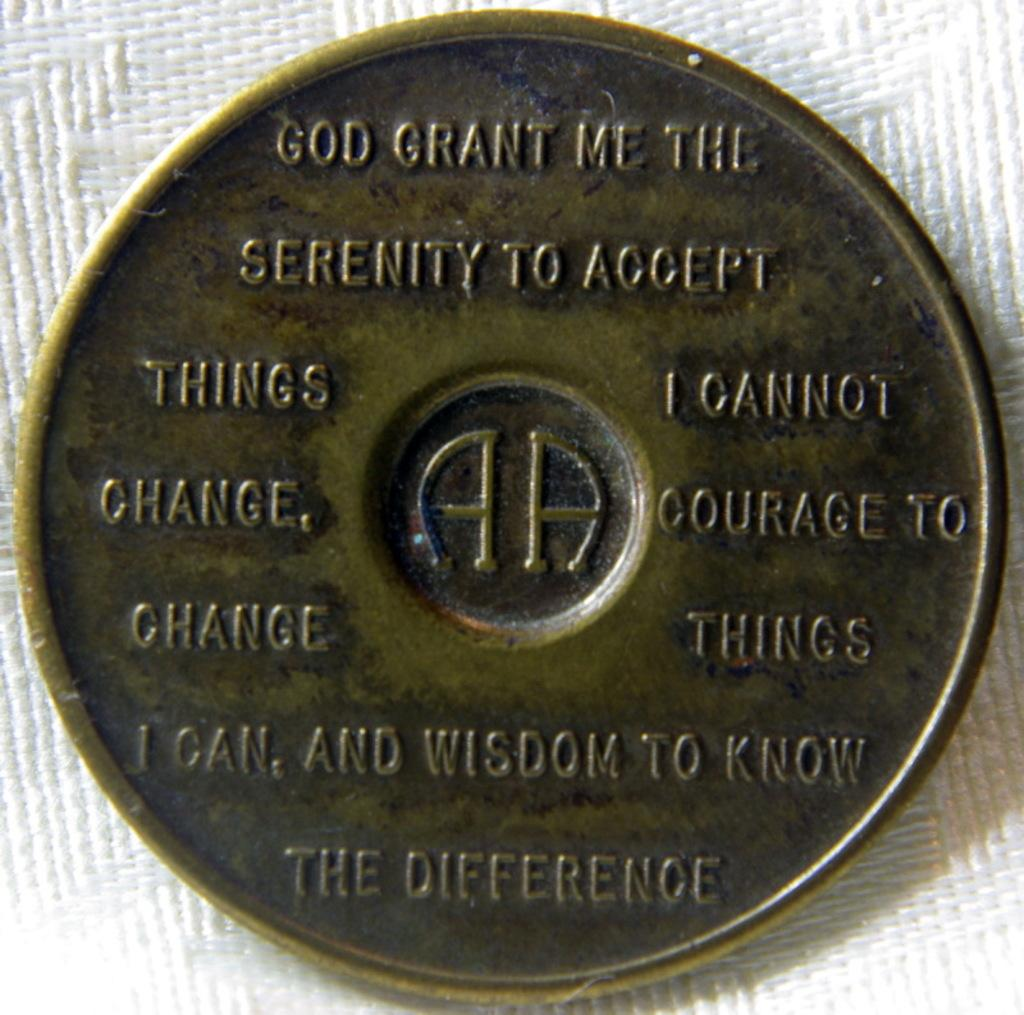Provide a one-sentence caption for the provided image. A gold coin token that has a prayer that says God grant me the. 